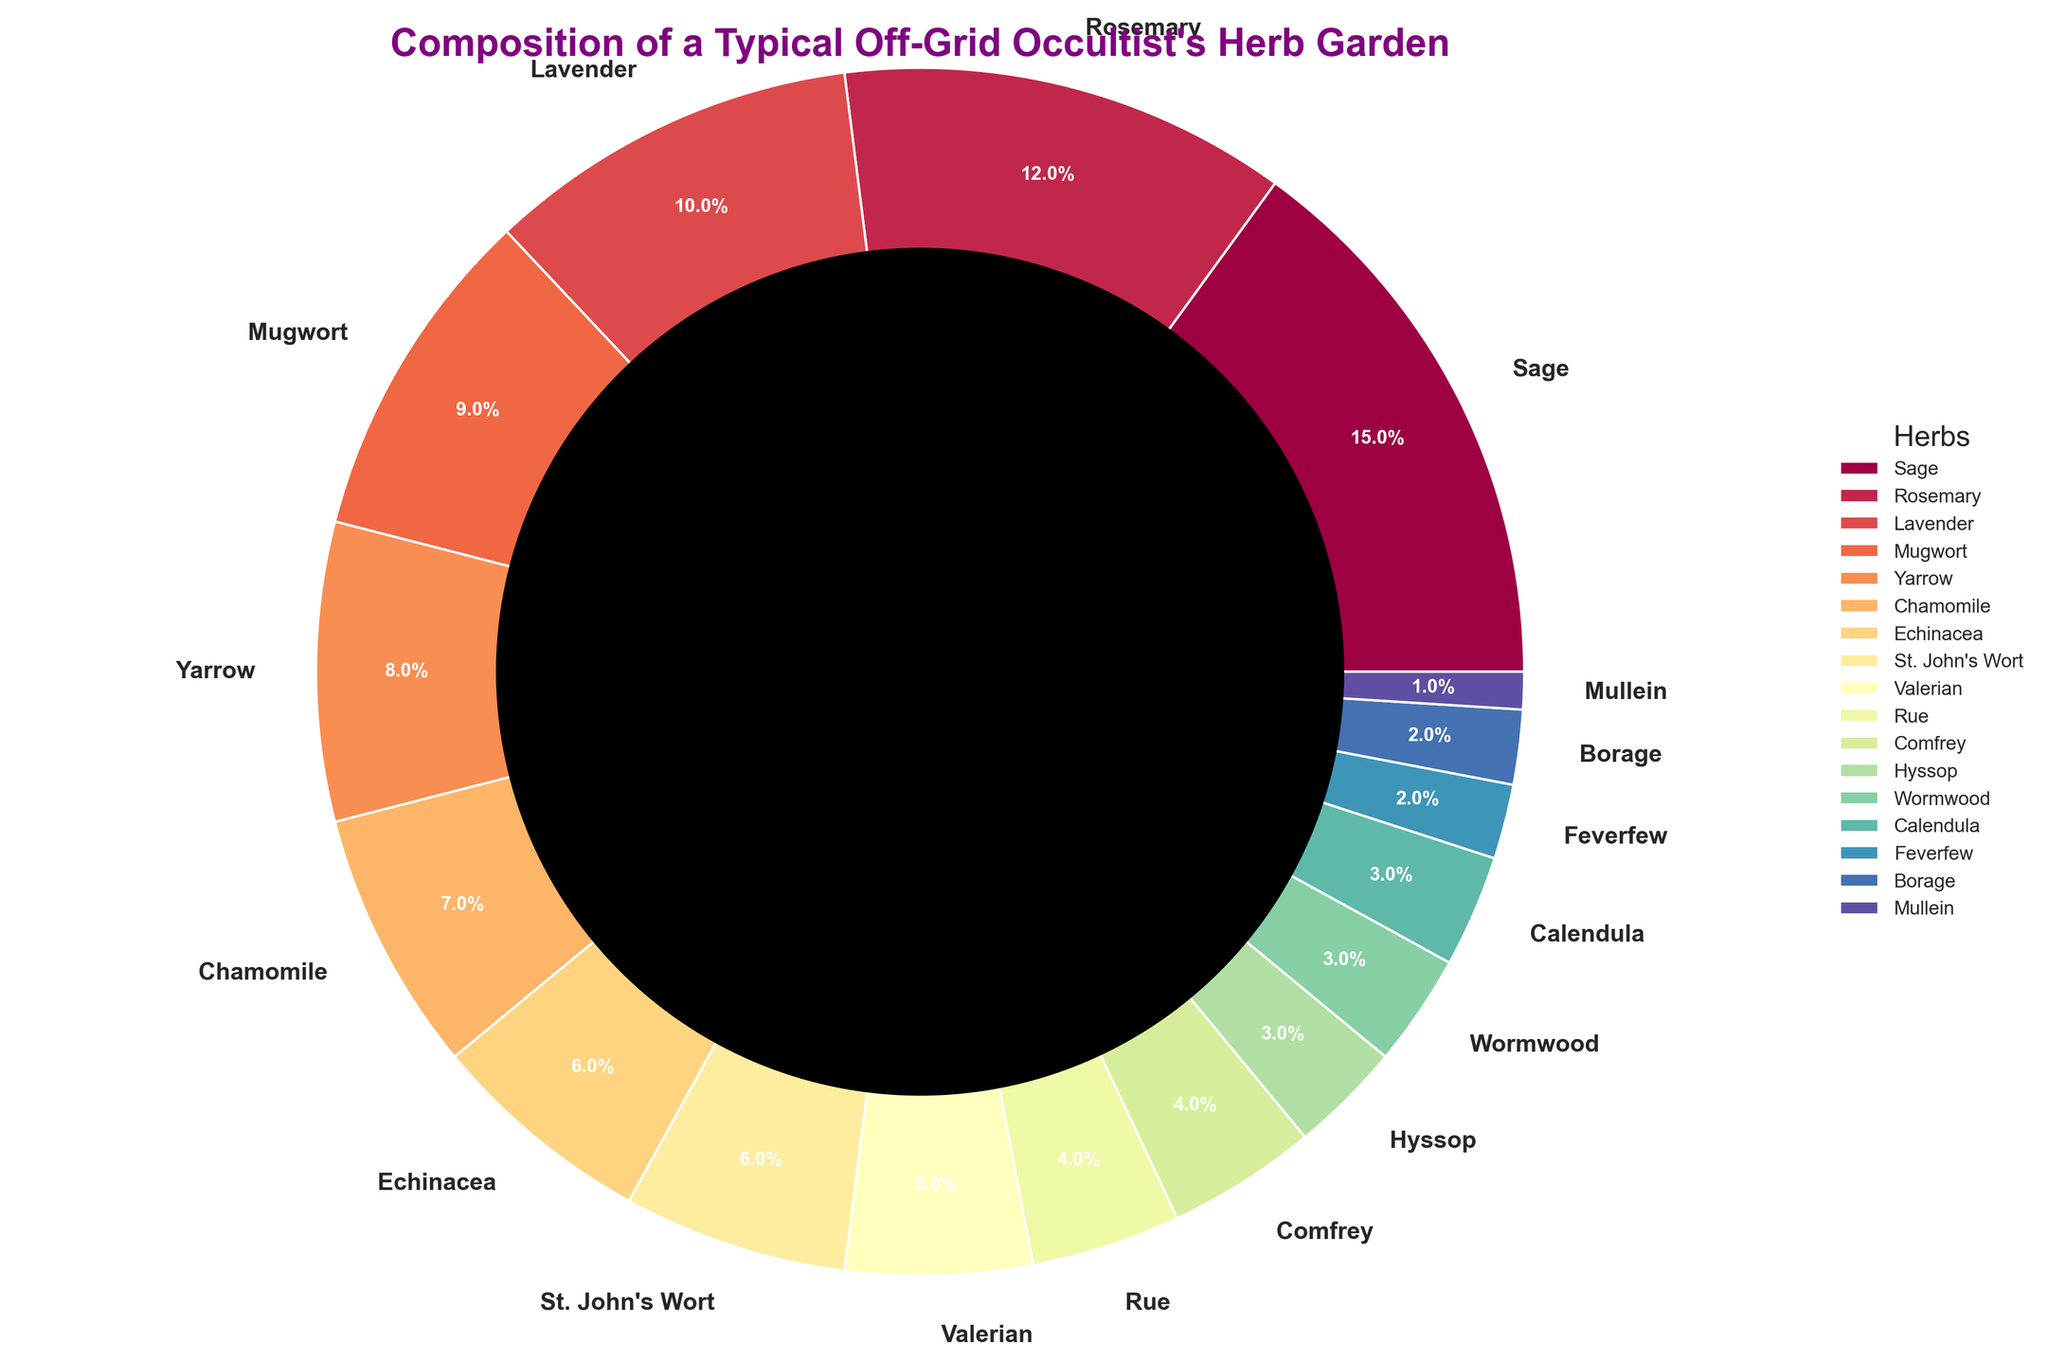What's the total percentage of Sage, Rosemary, and Lavender? Sum the percentages: Sage (15%) + Rosemary (12%) + Lavender (10%) = 15% + 12% + 10% = 37%
Answer: 37% Which herb has the smallest percentage? The smallest percentage value is Mullein at 1%
Answer: Mullein How many herbs have a percentage value less than 5%? Count all herbs with a percentage less than 5%: Rue (4%), Comfrey (4%), Hyssop (3%), Wormwood (3%), Calendula (3%), Feverfew (2%), Borage (2%), Mullein (1%). Total = 8 herbs
Answer: 8 What is the difference in percentage between the herb with the highest value and the herb with the lowest value? Identify the highest percentage (Sage at 15%) and the lowest percentage (Mullein at 1%), then subtract: 15% - 1% = 14%
Answer: 14% Are there more herbs with a percentage value above or below 5%? Count herbs above 5%: Sage (15%), Rosemary (12%), Lavender (10%), Mugwort (9%), Yarrow (8%), Chamomile (7%), Echinacea (6%), St. John's Wort (6%). Total = 8 herbs. Count herbs below 5%: Valerian (5%), Rue (4%), Comfrey (4%), Hyssop (3%), Wormwood (3%), Calendula (3%), Feverfew (2%), Borage (2%), Mullein (1%). Total = 9 herbs. Compare 8 vs. 9; 9 is greater.
Answer: Below What is the color of the segment representing Chamomile? Chamomile's segment is highlighted near the middle in a specific color; it's a shade of the color in the colormap used. Reference the colormap: Chamomile (7%) is roughly in the middle of the list and has a darkish blue shade.
Answer: Darkish blue Which herb is visually represented with the largest segment in the pie chart? The largest segment corresponds to Sage, which holds the highest percentage at 15%
Answer: Sage Comparing Echinacea and Valerian, which herb has a higher percentage? Echinacea has 6% and Valerian has 5%. Echinacea's percentage is higher.
Answer: Echinacea What's the average percentage of the herbs Valerian, Rue, Comfrey, and Hyssop? Sum the percentages: Valerian (5%) + Rue (4%) + Comfrey (4%) + Hyssop (3%) = 16%. Divide by the number of herbs: 16% / 4 = 4%
Answer: 4% Which herb has an equal percentage to St. John's Wort? St. John's Wort has a percentage of 6%, shared with Echinacea
Answer: Echinacea 